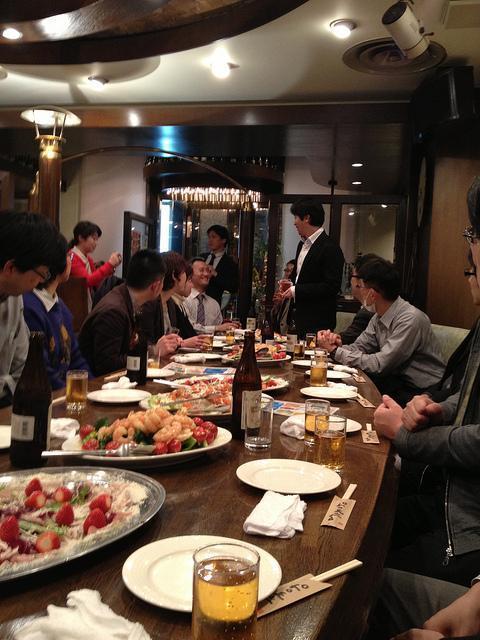How many people can be seen?
Give a very brief answer. 11. How many cups can you see?
Give a very brief answer. 1. 